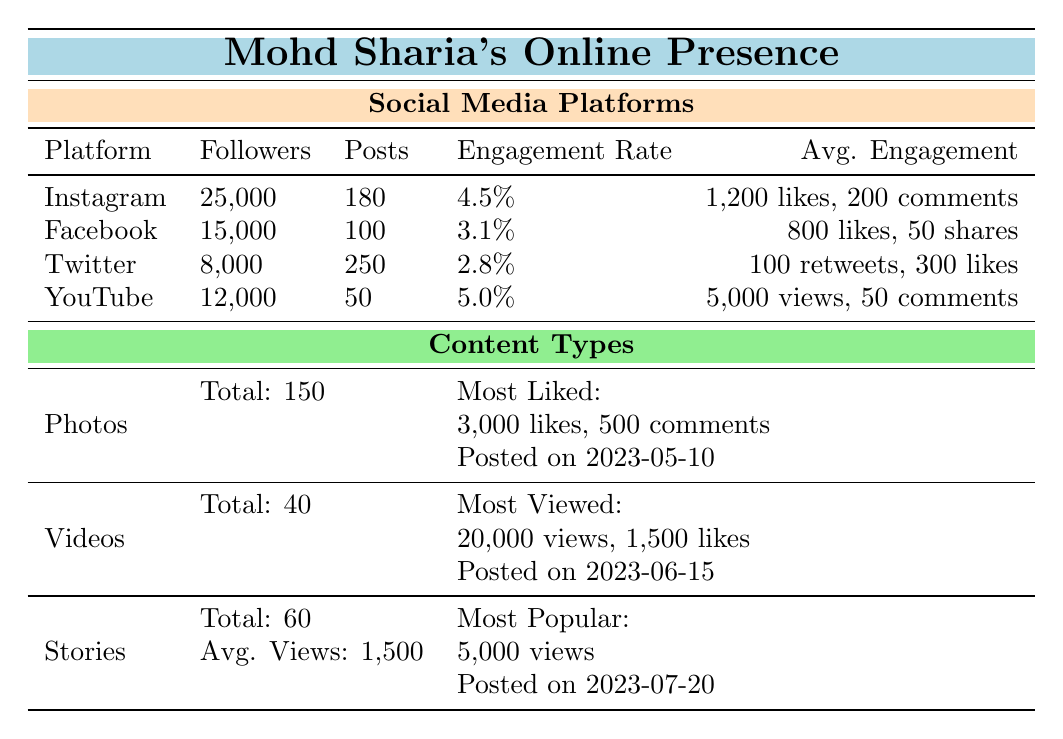What is the total number of followers across all social media platforms? To find the total followers, we add the followers from each platform: Instagram (25,000) + Facebook (15,000) + Twitter (8,000) + YouTube (12,000) = 60,000.
Answer: 60,000 Which platform has the highest engagement rate? Comparing the engagement rates: Instagram (4.5%), Facebook (3.1%), Twitter (2.8%), and YouTube (5.0%), we see that YouTube has the highest engagement rate of 5.0%.
Answer: YouTube How many more posts does Instagram have compared to Facebook? The number of posts on Instagram is 180 and on Facebook is 100. The difference is 180 - 100 = 80 posts, so Instagram has 80 more posts than Facebook.
Answer: 80 Is the average likes per post for Facebook greater than 800? The average likes per post for Facebook is exactly 800, which is not greater than 800, so the answer is no.
Answer: No What is the average total views for all videos posted on YouTube? The YouTube platform has 50 videos with an average of 5,000 views per video. Thus, the total views for all videos is 50 * 5,000 = 250,000. The average total views per video remains 5,000 as it does not require further calculation.
Answer: 5,000 What percentage of Mohd Sharia's total social media followers come from Instagram? To find this percentage, we use the number of Instagram followers (25,000) and the total followers (60,000): (25,000 / 60,000) * 100 = 41.67%. Therefore, approximately 41.67% of total followers come from Instagram.
Answer: 41.67% Which type of content has the most total items? The content types listed are Photos (150), Videos (40), and Stories (60). Comparing these, Photos have the most total items with 150.
Answer: Photos How does the engagement rate of Twitter compare to YouTube? Twitter has an engagement rate of 2.8% while YouTube has 5.0%. Since 2.8% is less than 5.0%, Twitter has a lower engagement rate than YouTube.
Answer: Lower Which social media platform has the least average likes per post? The platforms and their average likes per post are: Instagram (1,200), Facebook (800), Twitter (300), and YouTube (5,000). Twitter has the least average likes per post at 300.
Answer: Twitter 